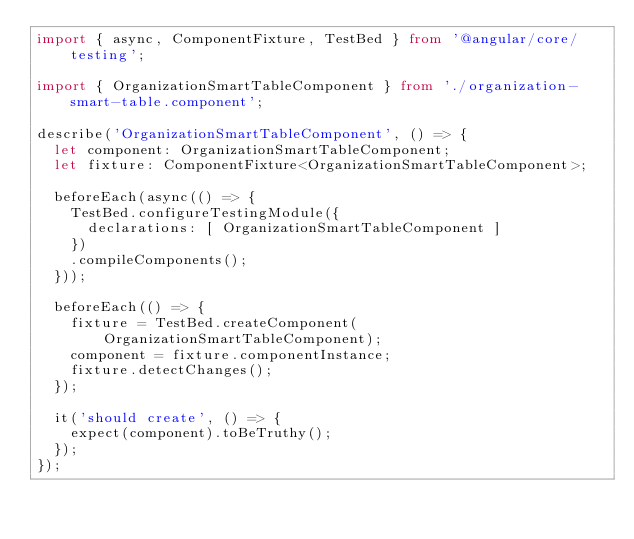<code> <loc_0><loc_0><loc_500><loc_500><_TypeScript_>import { async, ComponentFixture, TestBed } from '@angular/core/testing';

import { OrganizationSmartTableComponent } from './organization-smart-table.component';

describe('OrganizationSmartTableComponent', () => {
  let component: OrganizationSmartTableComponent;
  let fixture: ComponentFixture<OrganizationSmartTableComponent>;

  beforeEach(async(() => {
    TestBed.configureTestingModule({
      declarations: [ OrganizationSmartTableComponent ]
    })
    .compileComponents();
  }));

  beforeEach(() => {
    fixture = TestBed.createComponent(OrganizationSmartTableComponent);
    component = fixture.componentInstance;
    fixture.detectChanges();
  });

  it('should create', () => {
    expect(component).toBeTruthy();
  });
});
</code> 